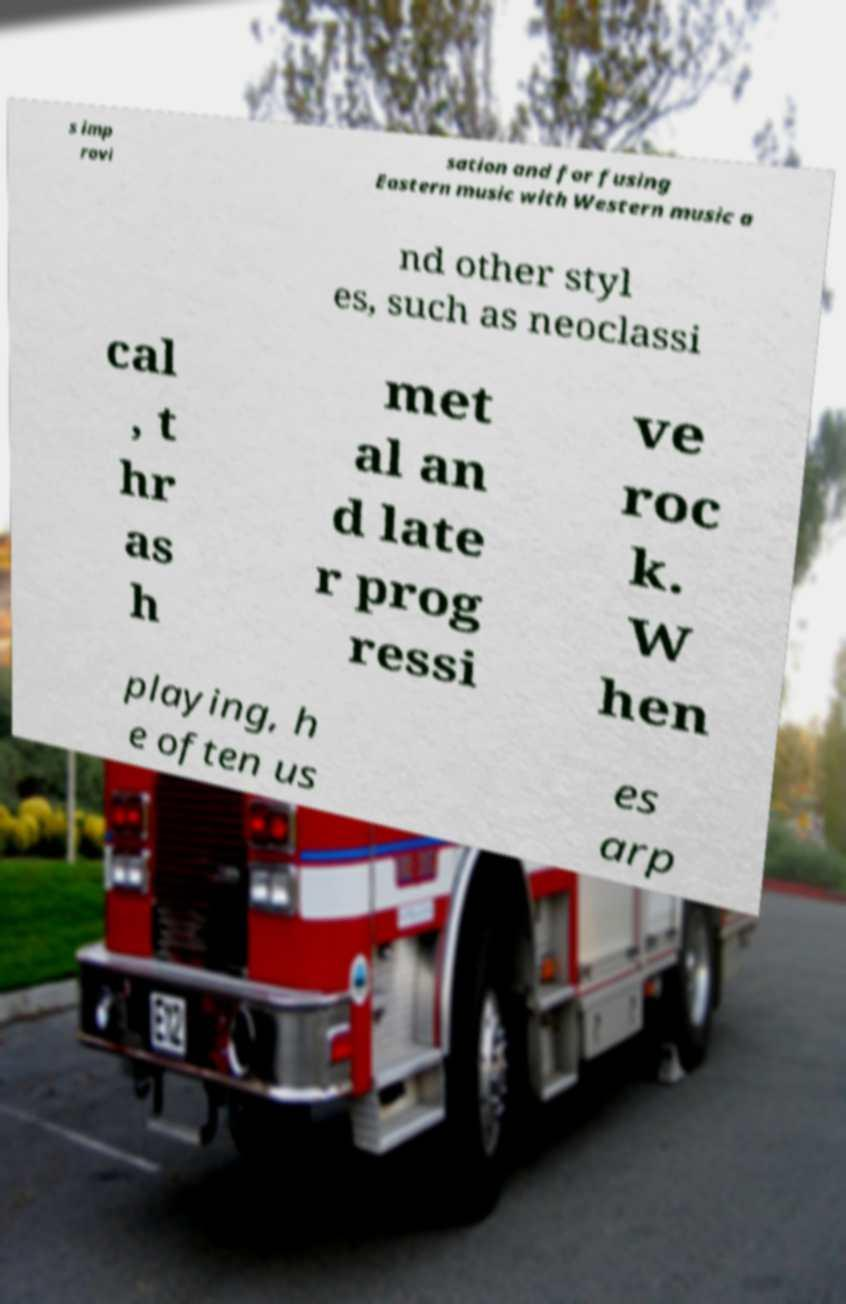Could you assist in decoding the text presented in this image and type it out clearly? s imp rovi sation and for fusing Eastern music with Western music a nd other styl es, such as neoclassi cal , t hr as h met al an d late r prog ressi ve roc k. W hen playing, h e often us es arp 